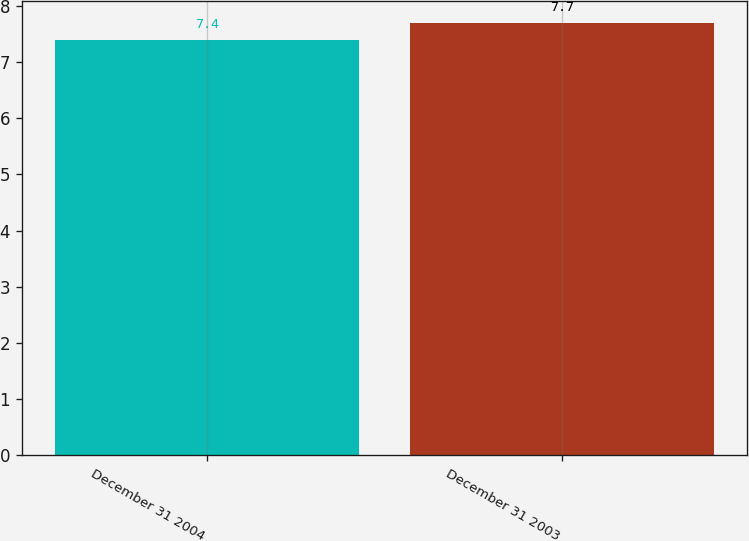Convert chart. <chart><loc_0><loc_0><loc_500><loc_500><bar_chart><fcel>December 31 2004<fcel>December 31 2003<nl><fcel>7.4<fcel>7.7<nl></chart> 